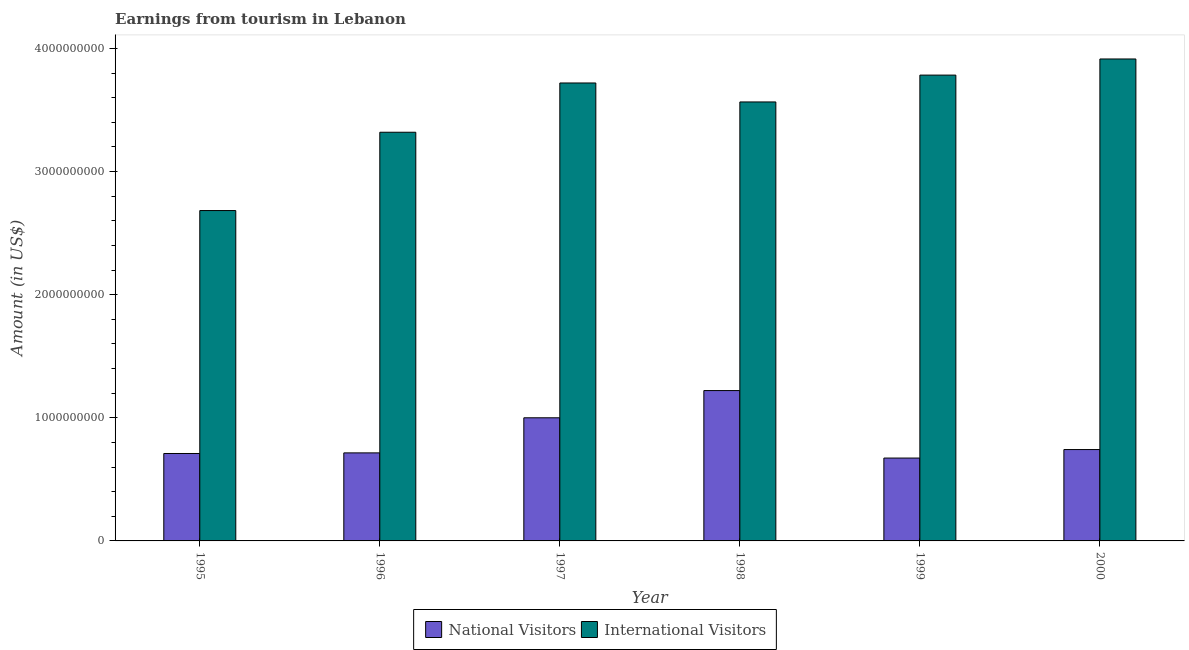How many different coloured bars are there?
Provide a short and direct response. 2. How many groups of bars are there?
Make the answer very short. 6. Are the number of bars on each tick of the X-axis equal?
Your answer should be very brief. Yes. How many bars are there on the 5th tick from the left?
Your answer should be very brief. 2. What is the label of the 4th group of bars from the left?
Your answer should be compact. 1998. In how many cases, is the number of bars for a given year not equal to the number of legend labels?
Give a very brief answer. 0. What is the amount earned from international visitors in 1997?
Your answer should be compact. 3.72e+09. Across all years, what is the maximum amount earned from international visitors?
Provide a short and direct response. 3.91e+09. Across all years, what is the minimum amount earned from national visitors?
Offer a terse response. 6.73e+08. In which year was the amount earned from international visitors maximum?
Give a very brief answer. 2000. What is the total amount earned from national visitors in the graph?
Ensure brevity in your answer.  5.06e+09. What is the difference between the amount earned from national visitors in 1995 and that in 1996?
Keep it short and to the point. -5.00e+06. What is the difference between the amount earned from national visitors in 1996 and the amount earned from international visitors in 1995?
Provide a short and direct response. 5.00e+06. What is the average amount earned from national visitors per year?
Offer a terse response. 8.44e+08. In how many years, is the amount earned from international visitors greater than 1400000000 US$?
Keep it short and to the point. 6. What is the ratio of the amount earned from international visitors in 1997 to that in 1998?
Your answer should be compact. 1.04. Is the difference between the amount earned from international visitors in 1995 and 1997 greater than the difference between the amount earned from national visitors in 1995 and 1997?
Your answer should be compact. No. What is the difference between the highest and the second highest amount earned from international visitors?
Offer a terse response. 1.31e+08. What is the difference between the highest and the lowest amount earned from international visitors?
Your answer should be very brief. 1.23e+09. In how many years, is the amount earned from international visitors greater than the average amount earned from international visitors taken over all years?
Provide a succinct answer. 4. What does the 1st bar from the left in 1997 represents?
Give a very brief answer. National Visitors. What does the 2nd bar from the right in 2000 represents?
Ensure brevity in your answer.  National Visitors. How many bars are there?
Give a very brief answer. 12. Are all the bars in the graph horizontal?
Ensure brevity in your answer.  No. How many years are there in the graph?
Provide a short and direct response. 6. Are the values on the major ticks of Y-axis written in scientific E-notation?
Keep it short and to the point. No. Does the graph contain any zero values?
Your answer should be very brief. No. Does the graph contain grids?
Your response must be concise. No. Where does the legend appear in the graph?
Make the answer very short. Bottom center. How many legend labels are there?
Your answer should be very brief. 2. How are the legend labels stacked?
Make the answer very short. Horizontal. What is the title of the graph?
Your answer should be compact. Earnings from tourism in Lebanon. Does "Underweight" appear as one of the legend labels in the graph?
Offer a terse response. No. What is the label or title of the X-axis?
Offer a terse response. Year. What is the label or title of the Y-axis?
Make the answer very short. Amount (in US$). What is the Amount (in US$) of National Visitors in 1995?
Keep it short and to the point. 7.10e+08. What is the Amount (in US$) in International Visitors in 1995?
Ensure brevity in your answer.  2.68e+09. What is the Amount (in US$) in National Visitors in 1996?
Keep it short and to the point. 7.15e+08. What is the Amount (in US$) in International Visitors in 1996?
Offer a very short reply. 3.32e+09. What is the Amount (in US$) of International Visitors in 1997?
Give a very brief answer. 3.72e+09. What is the Amount (in US$) of National Visitors in 1998?
Your answer should be compact. 1.22e+09. What is the Amount (in US$) in International Visitors in 1998?
Your answer should be very brief. 3.56e+09. What is the Amount (in US$) of National Visitors in 1999?
Keep it short and to the point. 6.73e+08. What is the Amount (in US$) of International Visitors in 1999?
Keep it short and to the point. 3.78e+09. What is the Amount (in US$) in National Visitors in 2000?
Offer a very short reply. 7.42e+08. What is the Amount (in US$) of International Visitors in 2000?
Offer a very short reply. 3.91e+09. Across all years, what is the maximum Amount (in US$) in National Visitors?
Your response must be concise. 1.22e+09. Across all years, what is the maximum Amount (in US$) in International Visitors?
Provide a succinct answer. 3.91e+09. Across all years, what is the minimum Amount (in US$) in National Visitors?
Keep it short and to the point. 6.73e+08. Across all years, what is the minimum Amount (in US$) in International Visitors?
Make the answer very short. 2.68e+09. What is the total Amount (in US$) in National Visitors in the graph?
Your answer should be compact. 5.06e+09. What is the total Amount (in US$) of International Visitors in the graph?
Give a very brief answer. 2.10e+1. What is the difference between the Amount (in US$) of National Visitors in 1995 and that in 1996?
Give a very brief answer. -5.00e+06. What is the difference between the Amount (in US$) in International Visitors in 1995 and that in 1996?
Your answer should be compact. -6.36e+08. What is the difference between the Amount (in US$) of National Visitors in 1995 and that in 1997?
Your answer should be compact. -2.90e+08. What is the difference between the Amount (in US$) of International Visitors in 1995 and that in 1997?
Ensure brevity in your answer.  -1.04e+09. What is the difference between the Amount (in US$) in National Visitors in 1995 and that in 1998?
Provide a succinct answer. -5.11e+08. What is the difference between the Amount (in US$) of International Visitors in 1995 and that in 1998?
Make the answer very short. -8.82e+08. What is the difference between the Amount (in US$) in National Visitors in 1995 and that in 1999?
Keep it short and to the point. 3.70e+07. What is the difference between the Amount (in US$) of International Visitors in 1995 and that in 1999?
Your response must be concise. -1.10e+09. What is the difference between the Amount (in US$) of National Visitors in 1995 and that in 2000?
Your answer should be compact. -3.20e+07. What is the difference between the Amount (in US$) in International Visitors in 1995 and that in 2000?
Your answer should be compact. -1.23e+09. What is the difference between the Amount (in US$) in National Visitors in 1996 and that in 1997?
Provide a succinct answer. -2.85e+08. What is the difference between the Amount (in US$) of International Visitors in 1996 and that in 1997?
Your answer should be compact. -4.00e+08. What is the difference between the Amount (in US$) in National Visitors in 1996 and that in 1998?
Offer a very short reply. -5.06e+08. What is the difference between the Amount (in US$) in International Visitors in 1996 and that in 1998?
Offer a terse response. -2.46e+08. What is the difference between the Amount (in US$) of National Visitors in 1996 and that in 1999?
Your response must be concise. 4.20e+07. What is the difference between the Amount (in US$) of International Visitors in 1996 and that in 1999?
Make the answer very short. -4.64e+08. What is the difference between the Amount (in US$) in National Visitors in 1996 and that in 2000?
Give a very brief answer. -2.70e+07. What is the difference between the Amount (in US$) of International Visitors in 1996 and that in 2000?
Offer a very short reply. -5.95e+08. What is the difference between the Amount (in US$) in National Visitors in 1997 and that in 1998?
Offer a very short reply. -2.21e+08. What is the difference between the Amount (in US$) of International Visitors in 1997 and that in 1998?
Ensure brevity in your answer.  1.54e+08. What is the difference between the Amount (in US$) in National Visitors in 1997 and that in 1999?
Ensure brevity in your answer.  3.27e+08. What is the difference between the Amount (in US$) in International Visitors in 1997 and that in 1999?
Ensure brevity in your answer.  -6.40e+07. What is the difference between the Amount (in US$) in National Visitors in 1997 and that in 2000?
Offer a terse response. 2.58e+08. What is the difference between the Amount (in US$) in International Visitors in 1997 and that in 2000?
Give a very brief answer. -1.95e+08. What is the difference between the Amount (in US$) in National Visitors in 1998 and that in 1999?
Your response must be concise. 5.48e+08. What is the difference between the Amount (in US$) of International Visitors in 1998 and that in 1999?
Your response must be concise. -2.18e+08. What is the difference between the Amount (in US$) of National Visitors in 1998 and that in 2000?
Provide a short and direct response. 4.79e+08. What is the difference between the Amount (in US$) of International Visitors in 1998 and that in 2000?
Make the answer very short. -3.49e+08. What is the difference between the Amount (in US$) of National Visitors in 1999 and that in 2000?
Offer a terse response. -6.90e+07. What is the difference between the Amount (in US$) in International Visitors in 1999 and that in 2000?
Give a very brief answer. -1.31e+08. What is the difference between the Amount (in US$) in National Visitors in 1995 and the Amount (in US$) in International Visitors in 1996?
Offer a very short reply. -2.61e+09. What is the difference between the Amount (in US$) of National Visitors in 1995 and the Amount (in US$) of International Visitors in 1997?
Ensure brevity in your answer.  -3.01e+09. What is the difference between the Amount (in US$) in National Visitors in 1995 and the Amount (in US$) in International Visitors in 1998?
Give a very brief answer. -2.86e+09. What is the difference between the Amount (in US$) of National Visitors in 1995 and the Amount (in US$) of International Visitors in 1999?
Offer a very short reply. -3.07e+09. What is the difference between the Amount (in US$) in National Visitors in 1995 and the Amount (in US$) in International Visitors in 2000?
Offer a very short reply. -3.20e+09. What is the difference between the Amount (in US$) in National Visitors in 1996 and the Amount (in US$) in International Visitors in 1997?
Provide a succinct answer. -3.00e+09. What is the difference between the Amount (in US$) of National Visitors in 1996 and the Amount (in US$) of International Visitors in 1998?
Offer a very short reply. -2.85e+09. What is the difference between the Amount (in US$) of National Visitors in 1996 and the Amount (in US$) of International Visitors in 1999?
Your answer should be compact. -3.07e+09. What is the difference between the Amount (in US$) in National Visitors in 1996 and the Amount (in US$) in International Visitors in 2000?
Give a very brief answer. -3.20e+09. What is the difference between the Amount (in US$) in National Visitors in 1997 and the Amount (in US$) in International Visitors in 1998?
Your answer should be very brief. -2.56e+09. What is the difference between the Amount (in US$) of National Visitors in 1997 and the Amount (in US$) of International Visitors in 1999?
Provide a short and direct response. -2.78e+09. What is the difference between the Amount (in US$) in National Visitors in 1997 and the Amount (in US$) in International Visitors in 2000?
Keep it short and to the point. -2.91e+09. What is the difference between the Amount (in US$) in National Visitors in 1998 and the Amount (in US$) in International Visitors in 1999?
Make the answer very short. -2.56e+09. What is the difference between the Amount (in US$) in National Visitors in 1998 and the Amount (in US$) in International Visitors in 2000?
Your response must be concise. -2.69e+09. What is the difference between the Amount (in US$) in National Visitors in 1999 and the Amount (in US$) in International Visitors in 2000?
Keep it short and to the point. -3.24e+09. What is the average Amount (in US$) of National Visitors per year?
Your answer should be compact. 8.44e+08. What is the average Amount (in US$) of International Visitors per year?
Give a very brief answer. 3.50e+09. In the year 1995, what is the difference between the Amount (in US$) of National Visitors and Amount (in US$) of International Visitors?
Your answer should be very brief. -1.97e+09. In the year 1996, what is the difference between the Amount (in US$) of National Visitors and Amount (in US$) of International Visitors?
Provide a short and direct response. -2.60e+09. In the year 1997, what is the difference between the Amount (in US$) in National Visitors and Amount (in US$) in International Visitors?
Offer a terse response. -2.72e+09. In the year 1998, what is the difference between the Amount (in US$) of National Visitors and Amount (in US$) of International Visitors?
Give a very brief answer. -2.34e+09. In the year 1999, what is the difference between the Amount (in US$) in National Visitors and Amount (in US$) in International Visitors?
Your response must be concise. -3.11e+09. In the year 2000, what is the difference between the Amount (in US$) in National Visitors and Amount (in US$) in International Visitors?
Keep it short and to the point. -3.17e+09. What is the ratio of the Amount (in US$) of National Visitors in 1995 to that in 1996?
Keep it short and to the point. 0.99. What is the ratio of the Amount (in US$) in International Visitors in 1995 to that in 1996?
Provide a short and direct response. 0.81. What is the ratio of the Amount (in US$) of National Visitors in 1995 to that in 1997?
Ensure brevity in your answer.  0.71. What is the ratio of the Amount (in US$) of International Visitors in 1995 to that in 1997?
Your answer should be compact. 0.72. What is the ratio of the Amount (in US$) in National Visitors in 1995 to that in 1998?
Provide a short and direct response. 0.58. What is the ratio of the Amount (in US$) of International Visitors in 1995 to that in 1998?
Keep it short and to the point. 0.75. What is the ratio of the Amount (in US$) of National Visitors in 1995 to that in 1999?
Offer a very short reply. 1.05. What is the ratio of the Amount (in US$) of International Visitors in 1995 to that in 1999?
Your answer should be compact. 0.71. What is the ratio of the Amount (in US$) in National Visitors in 1995 to that in 2000?
Keep it short and to the point. 0.96. What is the ratio of the Amount (in US$) of International Visitors in 1995 to that in 2000?
Keep it short and to the point. 0.69. What is the ratio of the Amount (in US$) in National Visitors in 1996 to that in 1997?
Ensure brevity in your answer.  0.71. What is the ratio of the Amount (in US$) of International Visitors in 1996 to that in 1997?
Your response must be concise. 0.89. What is the ratio of the Amount (in US$) in National Visitors in 1996 to that in 1998?
Offer a terse response. 0.59. What is the ratio of the Amount (in US$) in National Visitors in 1996 to that in 1999?
Your answer should be compact. 1.06. What is the ratio of the Amount (in US$) in International Visitors in 1996 to that in 1999?
Ensure brevity in your answer.  0.88. What is the ratio of the Amount (in US$) of National Visitors in 1996 to that in 2000?
Keep it short and to the point. 0.96. What is the ratio of the Amount (in US$) in International Visitors in 1996 to that in 2000?
Your response must be concise. 0.85. What is the ratio of the Amount (in US$) of National Visitors in 1997 to that in 1998?
Ensure brevity in your answer.  0.82. What is the ratio of the Amount (in US$) in International Visitors in 1997 to that in 1998?
Provide a succinct answer. 1.04. What is the ratio of the Amount (in US$) in National Visitors in 1997 to that in 1999?
Make the answer very short. 1.49. What is the ratio of the Amount (in US$) of International Visitors in 1997 to that in 1999?
Provide a succinct answer. 0.98. What is the ratio of the Amount (in US$) in National Visitors in 1997 to that in 2000?
Provide a succinct answer. 1.35. What is the ratio of the Amount (in US$) of International Visitors in 1997 to that in 2000?
Offer a terse response. 0.95. What is the ratio of the Amount (in US$) of National Visitors in 1998 to that in 1999?
Make the answer very short. 1.81. What is the ratio of the Amount (in US$) in International Visitors in 1998 to that in 1999?
Offer a very short reply. 0.94. What is the ratio of the Amount (in US$) in National Visitors in 1998 to that in 2000?
Keep it short and to the point. 1.65. What is the ratio of the Amount (in US$) of International Visitors in 1998 to that in 2000?
Your response must be concise. 0.91. What is the ratio of the Amount (in US$) of National Visitors in 1999 to that in 2000?
Give a very brief answer. 0.91. What is the ratio of the Amount (in US$) of International Visitors in 1999 to that in 2000?
Your response must be concise. 0.97. What is the difference between the highest and the second highest Amount (in US$) of National Visitors?
Make the answer very short. 2.21e+08. What is the difference between the highest and the second highest Amount (in US$) in International Visitors?
Keep it short and to the point. 1.31e+08. What is the difference between the highest and the lowest Amount (in US$) of National Visitors?
Offer a terse response. 5.48e+08. What is the difference between the highest and the lowest Amount (in US$) of International Visitors?
Your answer should be very brief. 1.23e+09. 